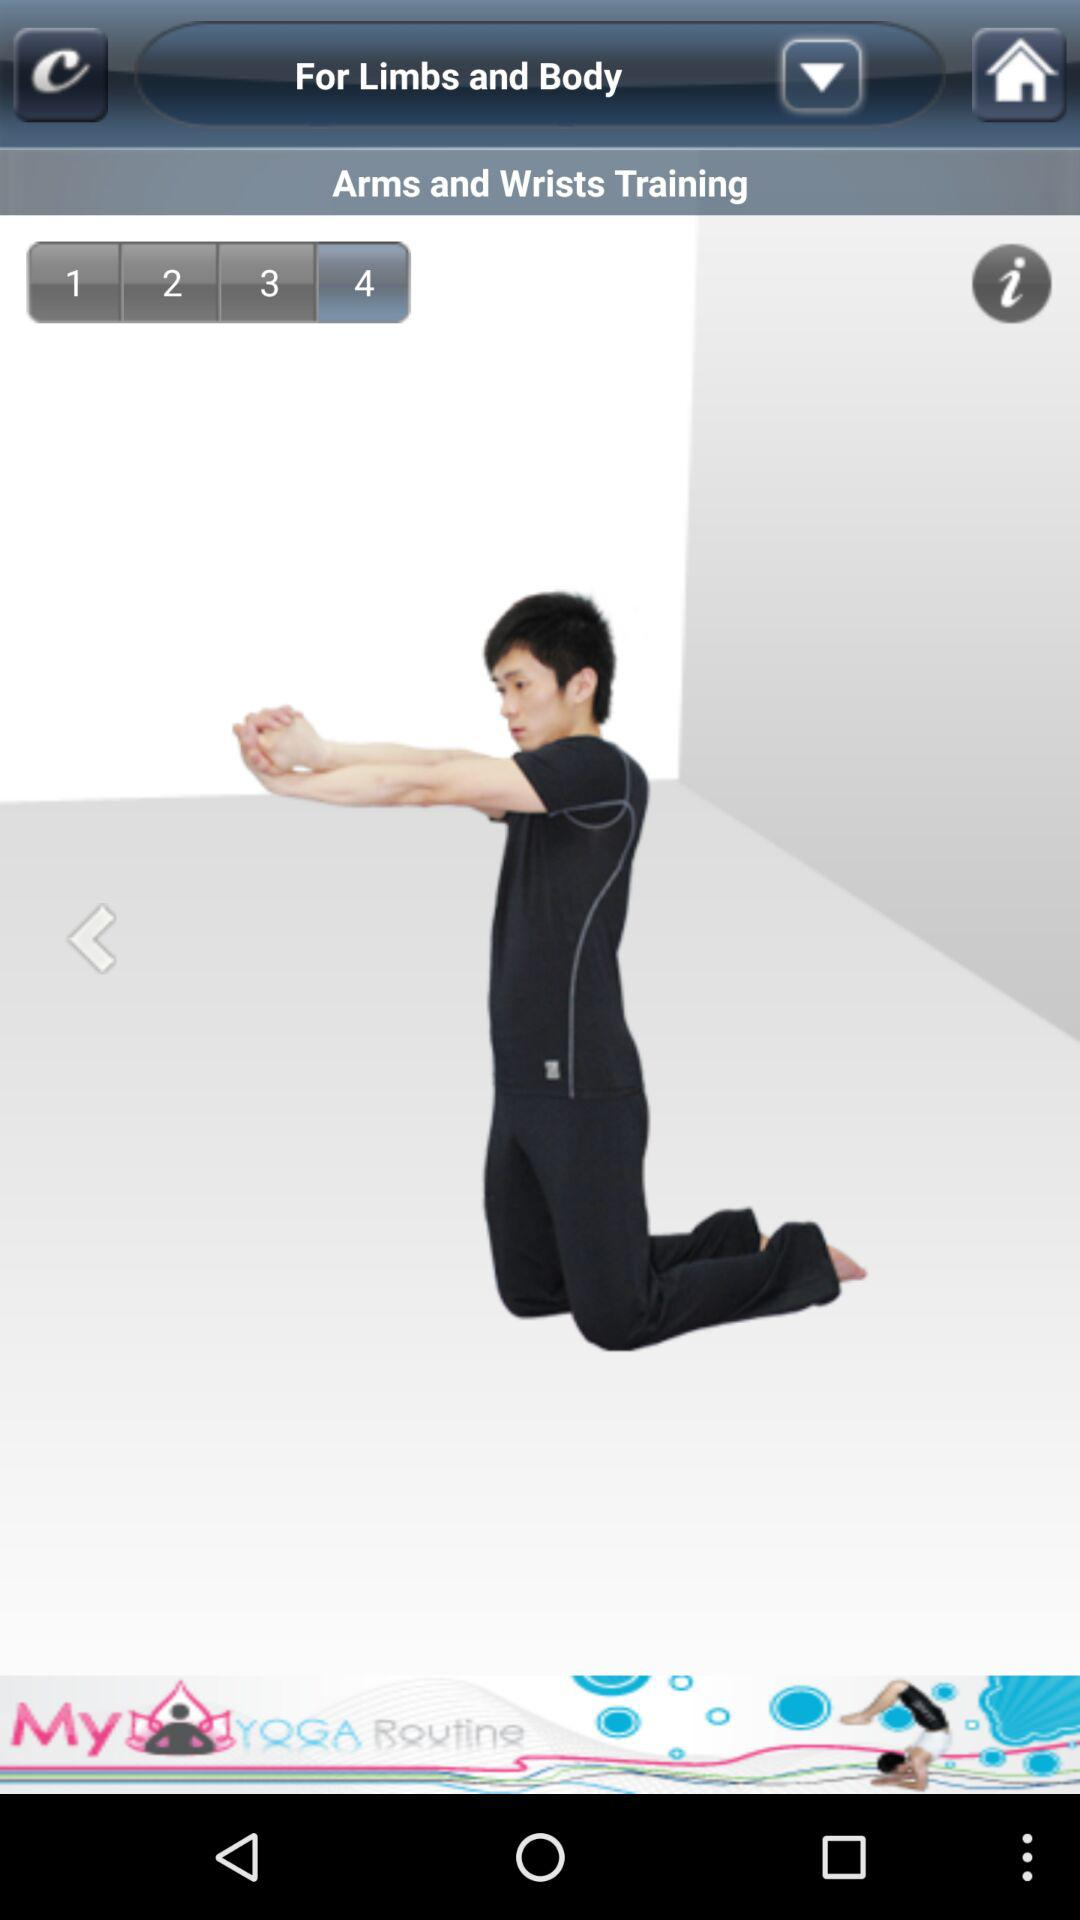What type of training is shown on the screen? The type of training shown on the screen is "Arms and Wrists Training". 